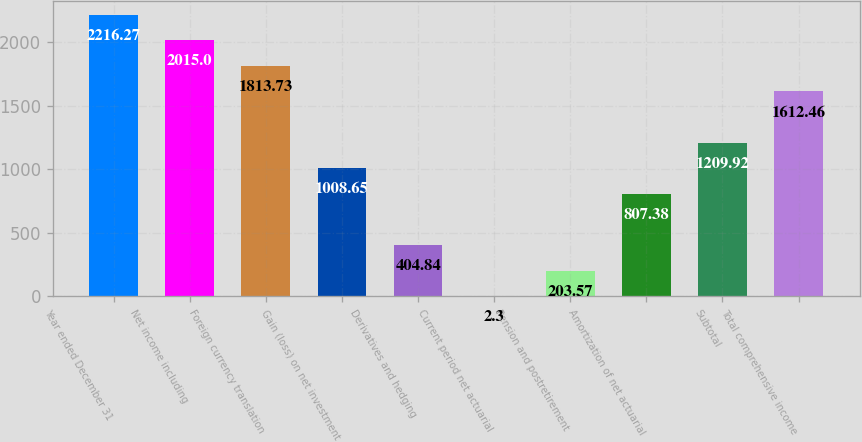Convert chart. <chart><loc_0><loc_0><loc_500><loc_500><bar_chart><fcel>Year ended December 31<fcel>Net income including<fcel>Foreign currency translation<fcel>Gain (loss) on net investment<fcel>Derivatives and hedging<fcel>Current period net actuarial<fcel>Pension and postretirement<fcel>Amortization of net actuarial<fcel>Subtotal<fcel>Total comprehensive income<nl><fcel>2216.27<fcel>2015<fcel>1813.73<fcel>1008.65<fcel>404.84<fcel>2.3<fcel>203.57<fcel>807.38<fcel>1209.92<fcel>1612.46<nl></chart> 